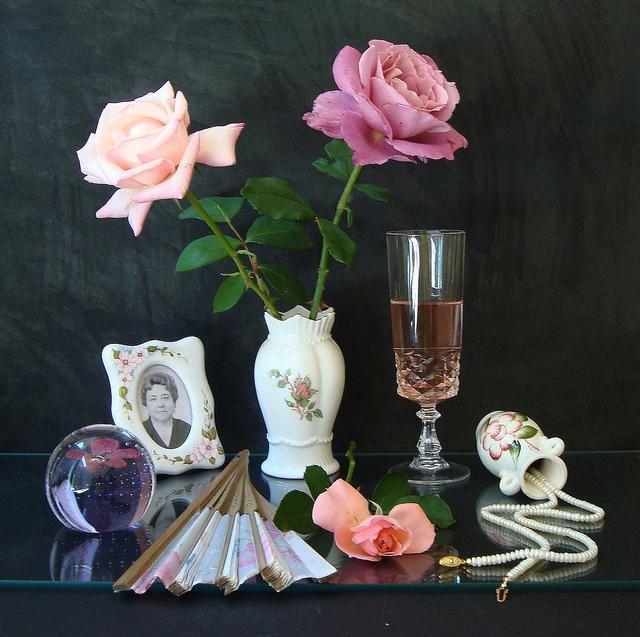How many vases can be seen?
Give a very brief answer. 2. 